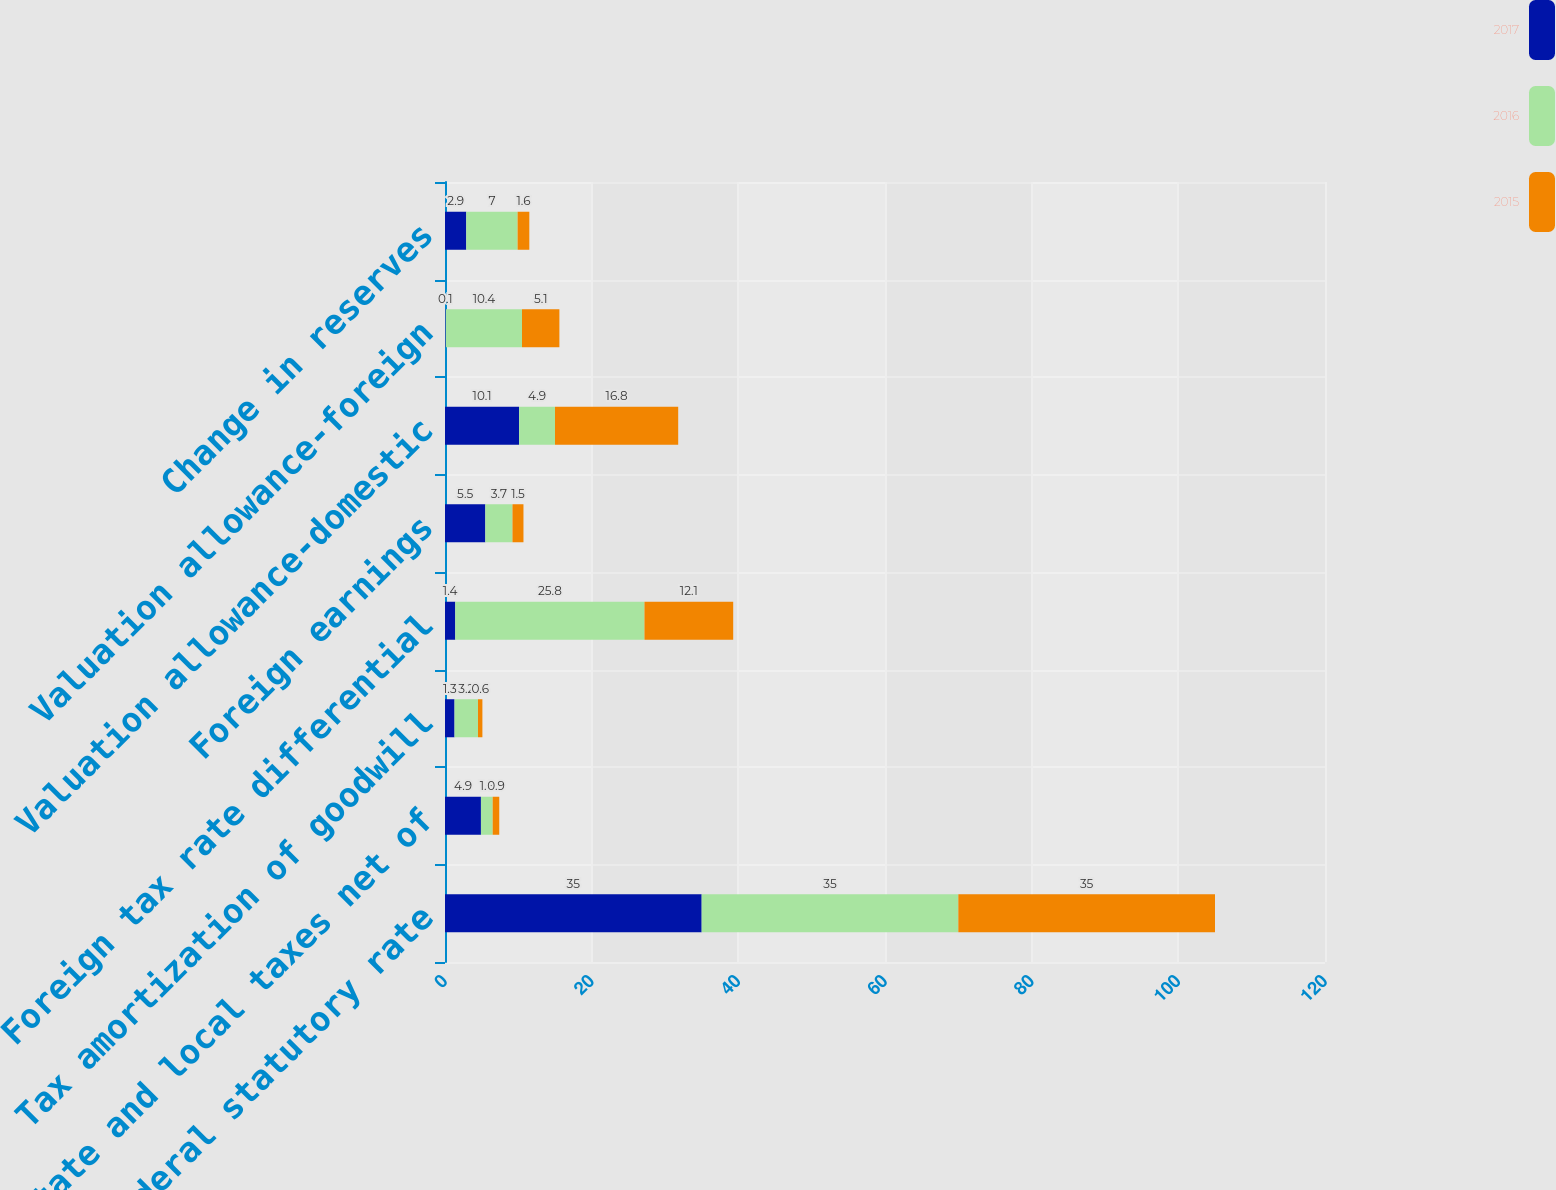Convert chart. <chart><loc_0><loc_0><loc_500><loc_500><stacked_bar_chart><ecel><fcel>US federal statutory rate<fcel>State and local taxes net of<fcel>Tax amortization of goodwill<fcel>Foreign tax rate differential<fcel>Foreign earnings<fcel>Valuation allowance-domestic<fcel>Valuation allowance-foreign<fcel>Change in reserves<nl><fcel>2017<fcel>35<fcel>4.9<fcel>1.3<fcel>1.4<fcel>5.5<fcel>10.1<fcel>0.1<fcel>2.9<nl><fcel>2016<fcel>35<fcel>1.6<fcel>3.2<fcel>25.8<fcel>3.7<fcel>4.9<fcel>10.4<fcel>7<nl><fcel>2015<fcel>35<fcel>0.9<fcel>0.6<fcel>12.1<fcel>1.5<fcel>16.8<fcel>5.1<fcel>1.6<nl></chart> 